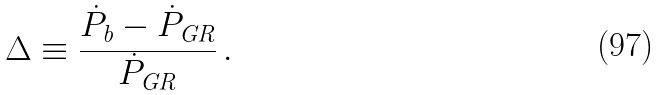Convert formula to latex. <formula><loc_0><loc_0><loc_500><loc_500>\Delta \equiv \frac { \dot { P } _ { \text {b} } - \dot { P } _ { \text {GR} } } { \dot { P } _ { \text {GR} } } \, .</formula> 